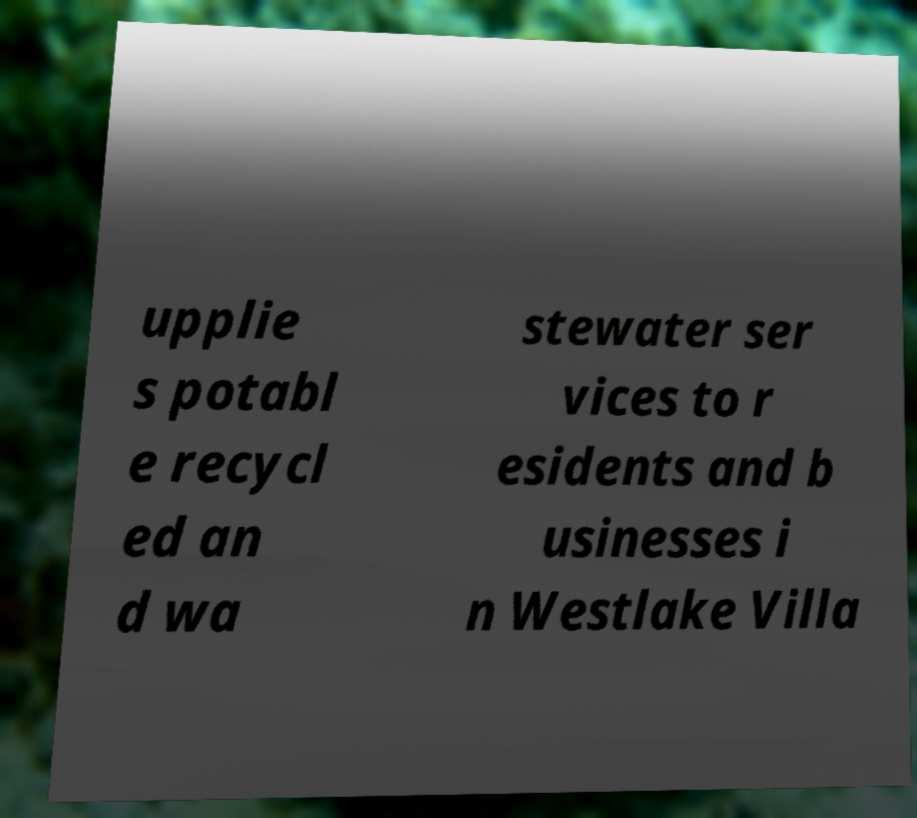There's text embedded in this image that I need extracted. Can you transcribe it verbatim? upplie s potabl e recycl ed an d wa stewater ser vices to r esidents and b usinesses i n Westlake Villa 